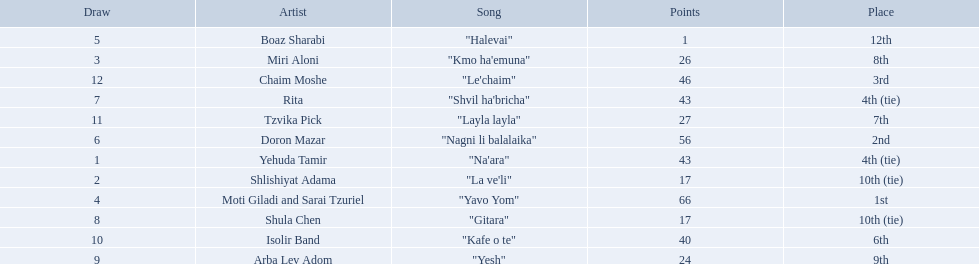What are the points? 43, 17, 26, 66, 1, 56, 43, 17, 24, 40, 27, 46. What is the least? 1. Which artist has that much Boaz Sharabi. Who are all of the artists? Yehuda Tamir, Shlishiyat Adama, Miri Aloni, Moti Giladi and Sarai Tzuriel, Boaz Sharabi, Doron Mazar, Rita, Shula Chen, Arba Lev Adom, Isolir Band, Tzvika Pick, Chaim Moshe. How many points did each score? 43, 17, 26, 66, 1, 56, 43, 17, 24, 40, 27, 46. And which artist had the least amount of points? Boaz Sharabi. What is the place of the contestant who received only 1 point? 12th. What is the name of the artist listed in the previous question? Boaz Sharabi. 